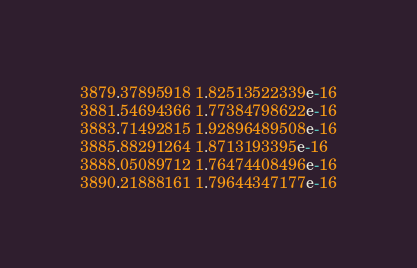<code> <loc_0><loc_0><loc_500><loc_500><_SQL_>3879.37895918 1.82513522339e-16
3881.54694366 1.77384798622e-16
3883.71492815 1.92896489508e-16
3885.88291264 1.8713193395e-16
3888.05089712 1.76474408496e-16
3890.21888161 1.79644347177e-16</code> 